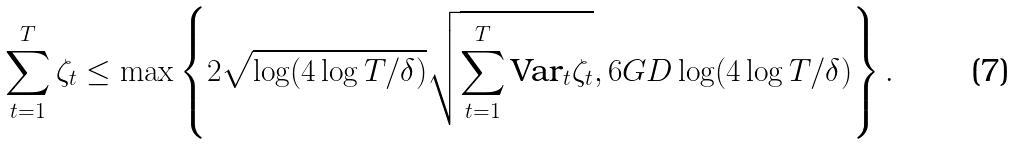<formula> <loc_0><loc_0><loc_500><loc_500>\sum _ { t = 1 } ^ { T } \zeta _ { t } \leq \max \left \{ 2 \sqrt { \log ( 4 \log T / \delta ) } \sqrt { \sum _ { t = 1 } ^ { T } \text {Var} _ { t } \zeta _ { t } } , 6 G D \log ( 4 \log T / \delta ) \right \} .</formula> 